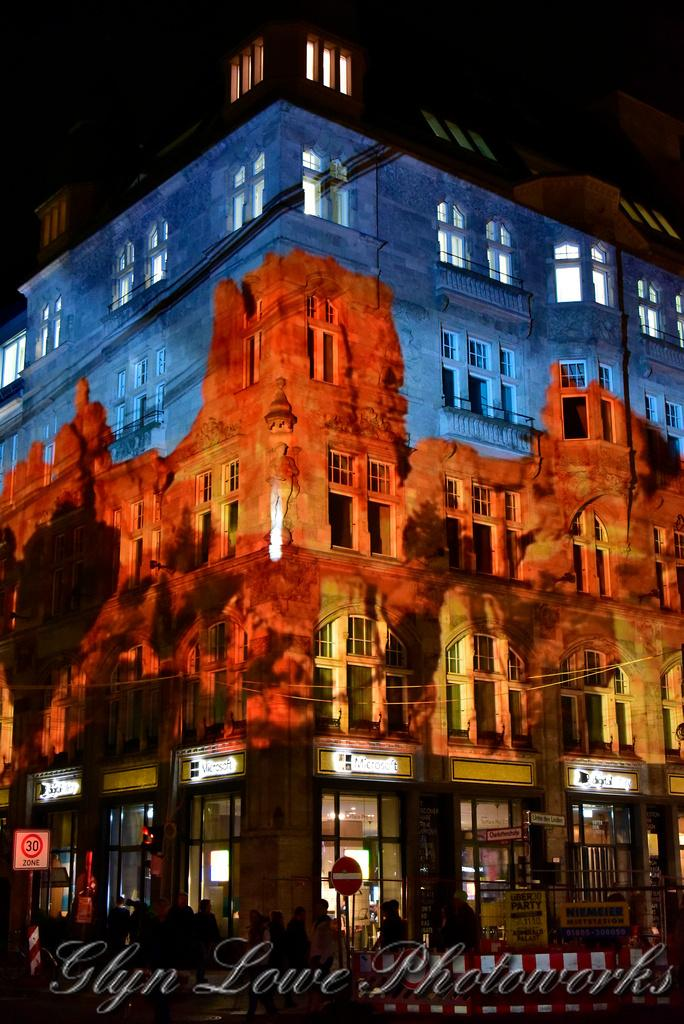What type of structure is visible in the image? There is a building in the image. What feature can be seen on the building? The building has windows. What type of signage is present in the image? There are name boards, sign boards, and banners in the image. What can be observed about the people in the image? There are people on a path in the image. How would you describe the lighting in the image? The background of the image is dark. What type of dirt can be seen on the grandmother's shoes in the image? There is no grandmother or shoes present in the image, so it is not possible to determine the type of dirt on any shoes. 